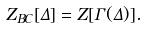<formula> <loc_0><loc_0><loc_500><loc_500>Z _ { B C } [ \Delta ] = Z [ \Gamma ( \Delta ) ] .</formula> 